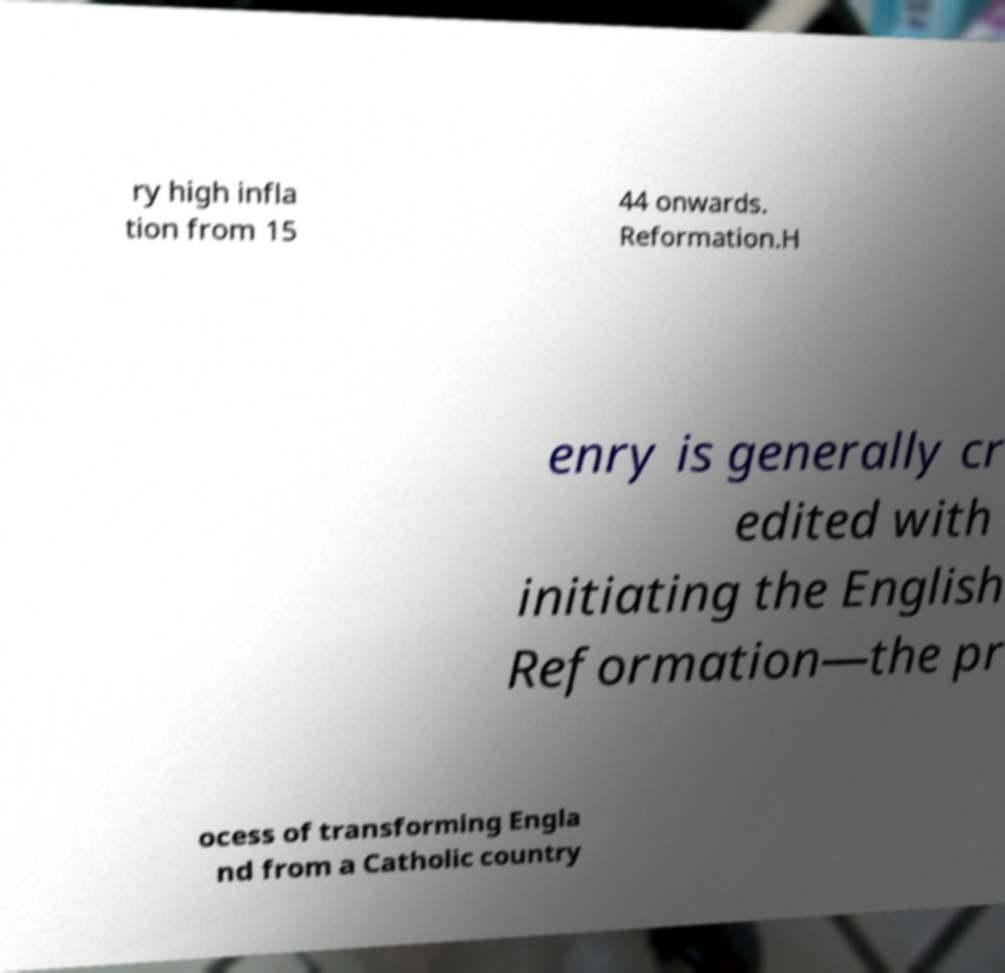Could you assist in decoding the text presented in this image and type it out clearly? ry high infla tion from 15 44 onwards. Reformation.H enry is generally cr edited with initiating the English Reformation—the pr ocess of transforming Engla nd from a Catholic country 